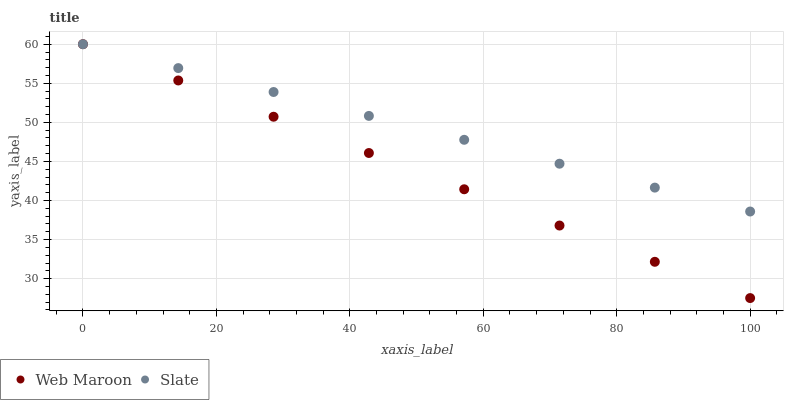Does Web Maroon have the minimum area under the curve?
Answer yes or no. Yes. Does Slate have the maximum area under the curve?
Answer yes or no. Yes. Does Web Maroon have the maximum area under the curve?
Answer yes or no. No. Is Slate the smoothest?
Answer yes or no. Yes. Is Web Maroon the roughest?
Answer yes or no. Yes. Is Web Maroon the smoothest?
Answer yes or no. No. Does Web Maroon have the lowest value?
Answer yes or no. Yes. Does Web Maroon have the highest value?
Answer yes or no. Yes. Does Web Maroon intersect Slate?
Answer yes or no. Yes. Is Web Maroon less than Slate?
Answer yes or no. No. Is Web Maroon greater than Slate?
Answer yes or no. No. 